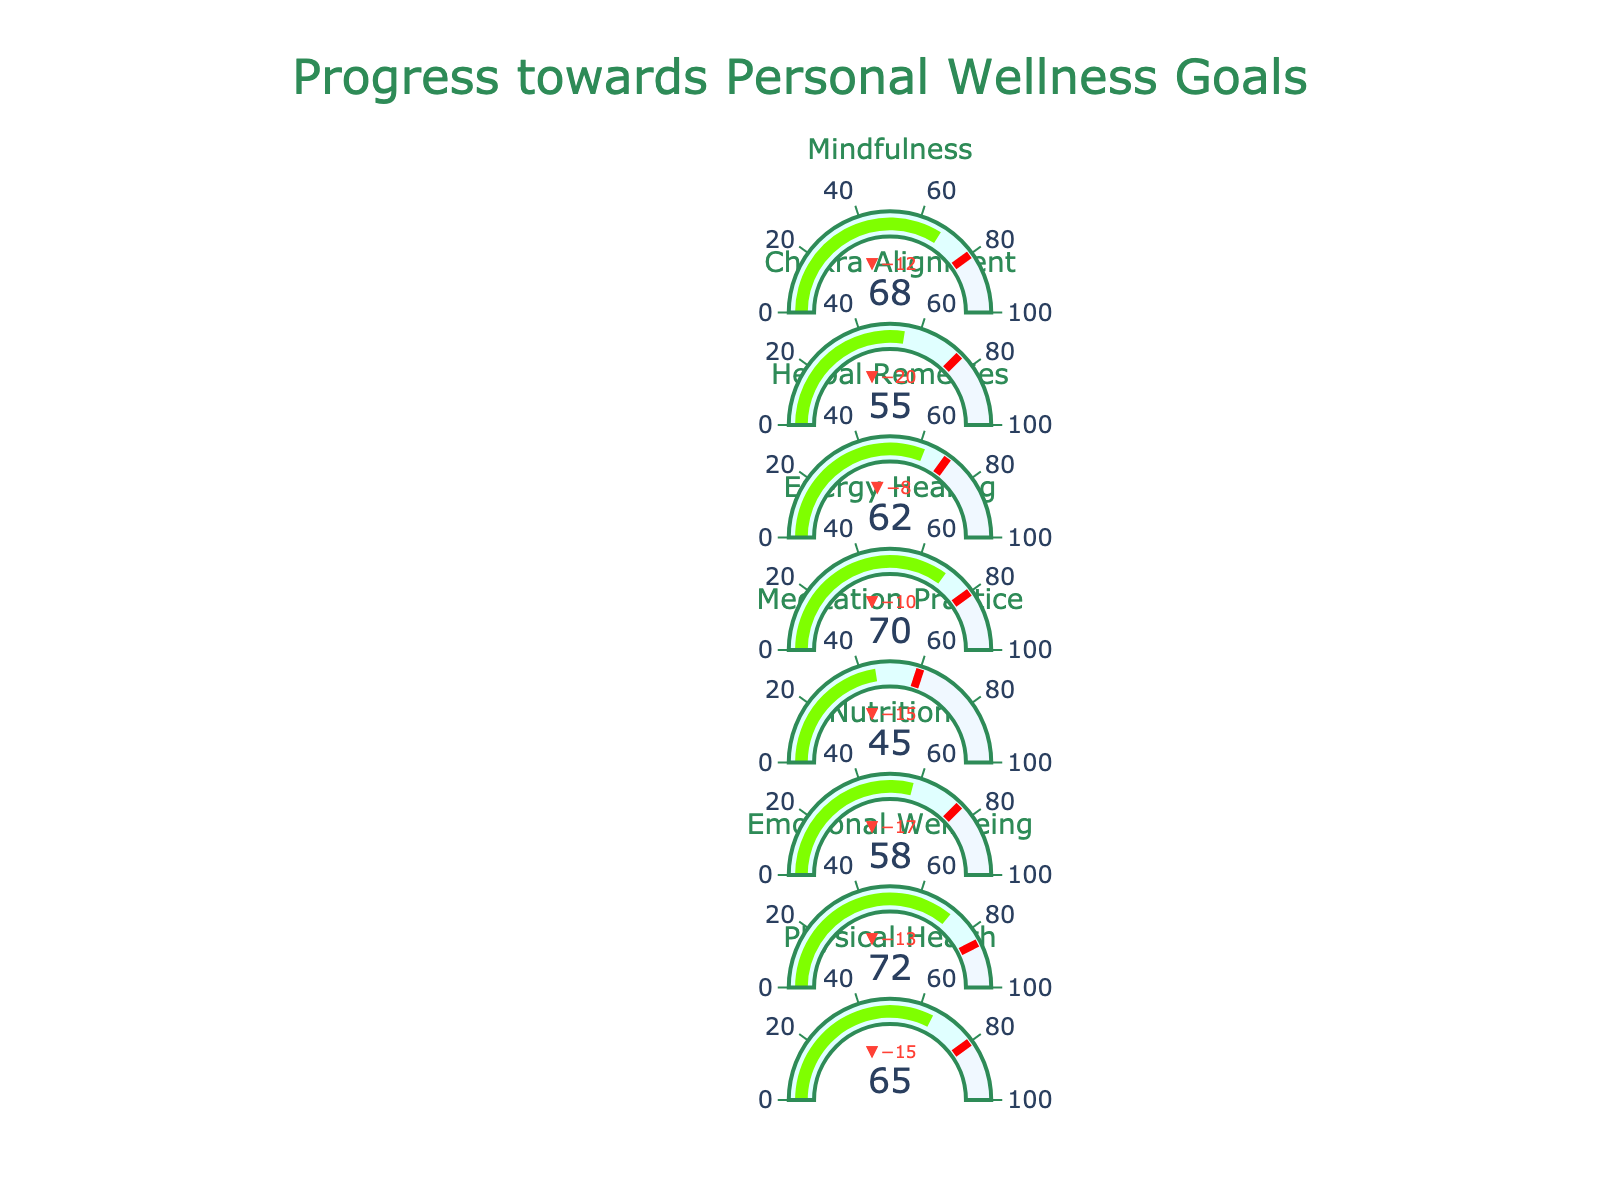What's the target value for Emotional Wellbeing? The target value for Emotional Wellbeing can be found in its respective bullet chart, usually indicated near the title with a reference marker or line showing the target.
Answer: 85 Which domain has the lowest actual value? By examining the actual values in each bullet chart, the lowest actual value will be the one with the smallest number.
Answer: Meditation Practice How much progress, in percentage, is remaining to reach the target in Physical Health? Calculate the percentage progress remaining by taking the difference between the target and the actual value, then divide by the target and multiply by 100. The calculation is ((80 - 65) / 80) * 100.
Answer: 18.75% Which holistic health domain is closest to its target value? To find the closest domain to its target, calculate the absolute difference between the actual and target values for each domain, and select the one with the smallest difference.
Answer: Emotional Wellbeing (difference of 13) What's the median actual value across all domains? To find the median, list all actual values in numerical order (45, 55, 58, 62, 65, 68, 70, 72), and identify the middle value(s). For even numbers, average the two middle values: (62 + 65) / 2.
Answer: 63.5 Which domain has exceeded half of its target value? Determine if the actual value for each domain is greater than half of its respective target value by calculating (Target/2) for each and comparing it to the actual value. For example, Physical Health has (80/2 = 40), and the actual value (65) is greater than 40. This applies to several domains such as Emotional Wellbeing, which exceeds halfway of its target (85/2 = 42.5, actual 72).
Answer: Physical Health, Emotional Wellbeing, Nutrition, Energy Healing, Herbal Remedies, Chakra Alignment, Mindfulness For which domain is the difference between the actual value and its range start the greatest? Calculate the difference between the actual value and the range start for each domain and identify the one with the highest value.
Answer: Emotional Wellbeing (72 - 0 = 72) What percentage of the total target values does the Chakra Alignment's actual value represent? Calculate the total of all target values first (80 + 85 + 75 + 60 + 80 + 70 + 75 + 80 = 605), then find the percentage using the actual value of Chakra Alignment (55). The calculation is (55 / 605) * 100.
Answer: 9.09% How many domains have their actual values in the upper half of their range? Examine each domain to see if the actual value falls within the top 50% of its range. The range is 0-100, so any actual value above 50 qualifies. Count the number of such domains.
Answer: 5 (Physical Health, Emotional Wellbeing, Energy Healing, Mindfulness, Herbal Remedies) In which domain is the actual value most below the target value? Calculate the difference between the target and actual values for each domain and identify the one with the largest negative difference.
Answer: Meditation Practice (60 - 45 = 15) 